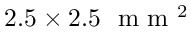<formula> <loc_0><loc_0><loc_500><loc_500>2 . 5 \times 2 . 5 m m ^ { 2 }</formula> 